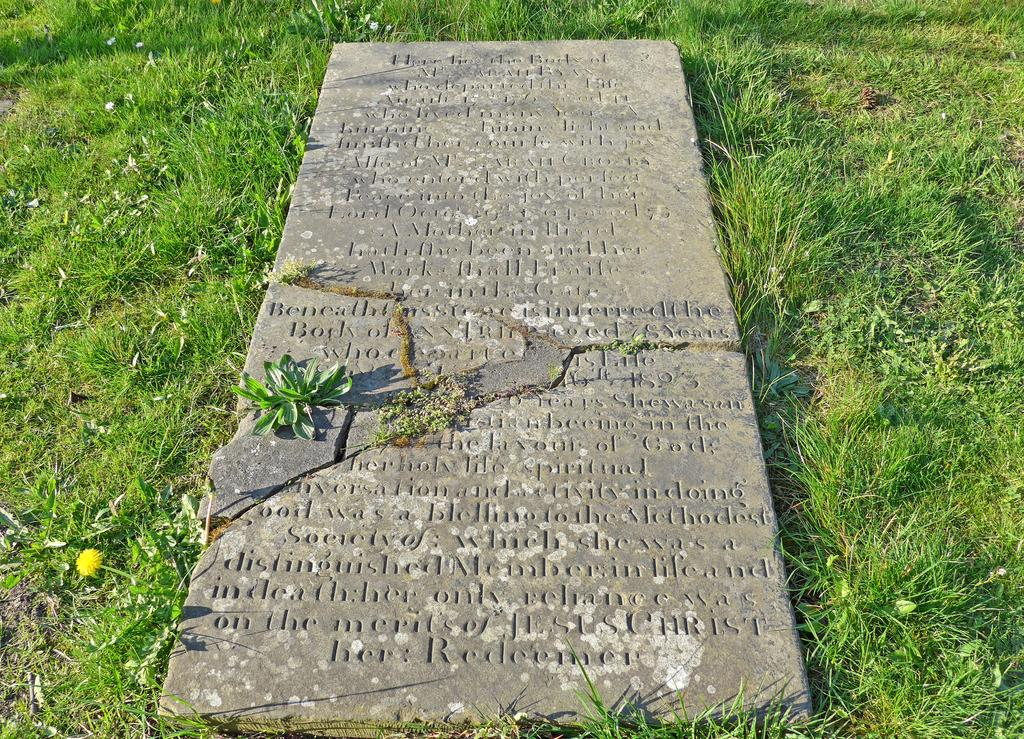What is the main subject in the image? There is a memorial in the image. What is the color of the memorial? The memorial is in ash color. What is the ground surface like around the memorial? The memorial is on green grass. How many children are playing with eggs near the memorial in the image? There are no children or eggs present in the image; it only features a memorial on green grass. 